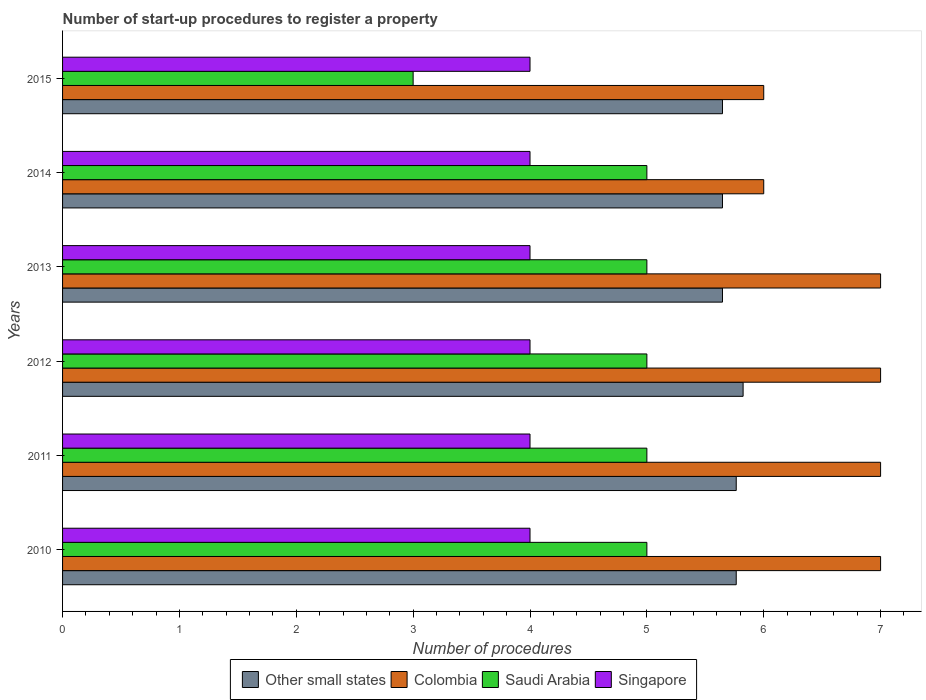How many different coloured bars are there?
Provide a succinct answer. 4. Are the number of bars per tick equal to the number of legend labels?
Keep it short and to the point. Yes. How many bars are there on the 3rd tick from the top?
Give a very brief answer. 4. In how many cases, is the number of bars for a given year not equal to the number of legend labels?
Make the answer very short. 0. What is the number of procedures required to register a property in Colombia in 2012?
Make the answer very short. 7. Across all years, what is the maximum number of procedures required to register a property in Saudi Arabia?
Keep it short and to the point. 5. Across all years, what is the minimum number of procedures required to register a property in Saudi Arabia?
Give a very brief answer. 3. In which year was the number of procedures required to register a property in Singapore maximum?
Offer a terse response. 2010. In which year was the number of procedures required to register a property in Saudi Arabia minimum?
Keep it short and to the point. 2015. What is the total number of procedures required to register a property in Singapore in the graph?
Offer a terse response. 24. What is the difference between the number of procedures required to register a property in Singapore in 2011 and that in 2012?
Your answer should be compact. 0. What is the difference between the number of procedures required to register a property in Saudi Arabia in 2010 and the number of procedures required to register a property in Other small states in 2011?
Provide a succinct answer. -0.76. What is the average number of procedures required to register a property in Other small states per year?
Make the answer very short. 5.72. In the year 2014, what is the difference between the number of procedures required to register a property in Saudi Arabia and number of procedures required to register a property in Colombia?
Give a very brief answer. -1. Is the difference between the number of procedures required to register a property in Saudi Arabia in 2011 and 2012 greater than the difference between the number of procedures required to register a property in Colombia in 2011 and 2012?
Ensure brevity in your answer.  No. What is the difference between the highest and the second highest number of procedures required to register a property in Saudi Arabia?
Keep it short and to the point. 0. What is the difference between the highest and the lowest number of procedures required to register a property in Colombia?
Offer a very short reply. 1. In how many years, is the number of procedures required to register a property in Saudi Arabia greater than the average number of procedures required to register a property in Saudi Arabia taken over all years?
Provide a succinct answer. 5. Is the sum of the number of procedures required to register a property in Singapore in 2010 and 2014 greater than the maximum number of procedures required to register a property in Other small states across all years?
Give a very brief answer. Yes. What does the 2nd bar from the top in 2015 represents?
Keep it short and to the point. Saudi Arabia. What does the 4th bar from the bottom in 2014 represents?
Offer a very short reply. Singapore. How many years are there in the graph?
Ensure brevity in your answer.  6. What is the difference between two consecutive major ticks on the X-axis?
Your response must be concise. 1. Are the values on the major ticks of X-axis written in scientific E-notation?
Ensure brevity in your answer.  No. Does the graph contain grids?
Your answer should be very brief. No. How many legend labels are there?
Keep it short and to the point. 4. What is the title of the graph?
Keep it short and to the point. Number of start-up procedures to register a property. What is the label or title of the X-axis?
Offer a terse response. Number of procedures. What is the Number of procedures of Other small states in 2010?
Offer a very short reply. 5.76. What is the Number of procedures in Colombia in 2010?
Offer a terse response. 7. What is the Number of procedures in Saudi Arabia in 2010?
Make the answer very short. 5. What is the Number of procedures of Other small states in 2011?
Ensure brevity in your answer.  5.76. What is the Number of procedures in Colombia in 2011?
Ensure brevity in your answer.  7. What is the Number of procedures in Saudi Arabia in 2011?
Provide a short and direct response. 5. What is the Number of procedures in Singapore in 2011?
Give a very brief answer. 4. What is the Number of procedures in Other small states in 2012?
Make the answer very short. 5.82. What is the Number of procedures in Colombia in 2012?
Your response must be concise. 7. What is the Number of procedures of Other small states in 2013?
Your answer should be very brief. 5.65. What is the Number of procedures in Other small states in 2014?
Keep it short and to the point. 5.65. What is the Number of procedures of Saudi Arabia in 2014?
Provide a succinct answer. 5. What is the Number of procedures in Singapore in 2014?
Provide a short and direct response. 4. What is the Number of procedures of Other small states in 2015?
Keep it short and to the point. 5.65. What is the Number of procedures of Saudi Arabia in 2015?
Keep it short and to the point. 3. What is the Number of procedures of Singapore in 2015?
Keep it short and to the point. 4. Across all years, what is the maximum Number of procedures of Other small states?
Offer a very short reply. 5.82. Across all years, what is the maximum Number of procedures in Colombia?
Offer a very short reply. 7. Across all years, what is the maximum Number of procedures in Saudi Arabia?
Your answer should be very brief. 5. Across all years, what is the maximum Number of procedures of Singapore?
Offer a very short reply. 4. Across all years, what is the minimum Number of procedures in Other small states?
Give a very brief answer. 5.65. Across all years, what is the minimum Number of procedures in Saudi Arabia?
Offer a very short reply. 3. What is the total Number of procedures of Other small states in the graph?
Ensure brevity in your answer.  34.29. What is the total Number of procedures of Colombia in the graph?
Your response must be concise. 40. What is the total Number of procedures in Singapore in the graph?
Give a very brief answer. 24. What is the difference between the Number of procedures in Colombia in 2010 and that in 2011?
Your answer should be very brief. 0. What is the difference between the Number of procedures in Singapore in 2010 and that in 2011?
Give a very brief answer. 0. What is the difference between the Number of procedures in Other small states in 2010 and that in 2012?
Your response must be concise. -0.06. What is the difference between the Number of procedures in Colombia in 2010 and that in 2012?
Provide a succinct answer. 0. What is the difference between the Number of procedures in Saudi Arabia in 2010 and that in 2012?
Keep it short and to the point. 0. What is the difference between the Number of procedures in Singapore in 2010 and that in 2012?
Offer a terse response. 0. What is the difference between the Number of procedures in Other small states in 2010 and that in 2013?
Give a very brief answer. 0.12. What is the difference between the Number of procedures of Saudi Arabia in 2010 and that in 2013?
Give a very brief answer. 0. What is the difference between the Number of procedures in Other small states in 2010 and that in 2014?
Provide a succinct answer. 0.12. What is the difference between the Number of procedures in Saudi Arabia in 2010 and that in 2014?
Offer a terse response. 0. What is the difference between the Number of procedures of Singapore in 2010 and that in 2014?
Ensure brevity in your answer.  0. What is the difference between the Number of procedures in Other small states in 2010 and that in 2015?
Provide a short and direct response. 0.12. What is the difference between the Number of procedures of Saudi Arabia in 2010 and that in 2015?
Give a very brief answer. 2. What is the difference between the Number of procedures of Singapore in 2010 and that in 2015?
Give a very brief answer. 0. What is the difference between the Number of procedures in Other small states in 2011 and that in 2012?
Provide a short and direct response. -0.06. What is the difference between the Number of procedures in Saudi Arabia in 2011 and that in 2012?
Keep it short and to the point. 0. What is the difference between the Number of procedures of Other small states in 2011 and that in 2013?
Your answer should be very brief. 0.12. What is the difference between the Number of procedures of Other small states in 2011 and that in 2014?
Ensure brevity in your answer.  0.12. What is the difference between the Number of procedures in Colombia in 2011 and that in 2014?
Provide a succinct answer. 1. What is the difference between the Number of procedures of Saudi Arabia in 2011 and that in 2014?
Give a very brief answer. 0. What is the difference between the Number of procedures of Other small states in 2011 and that in 2015?
Offer a very short reply. 0.12. What is the difference between the Number of procedures in Colombia in 2011 and that in 2015?
Provide a short and direct response. 1. What is the difference between the Number of procedures in Saudi Arabia in 2011 and that in 2015?
Give a very brief answer. 2. What is the difference between the Number of procedures of Other small states in 2012 and that in 2013?
Offer a terse response. 0.18. What is the difference between the Number of procedures in Colombia in 2012 and that in 2013?
Provide a succinct answer. 0. What is the difference between the Number of procedures in Other small states in 2012 and that in 2014?
Ensure brevity in your answer.  0.18. What is the difference between the Number of procedures of Saudi Arabia in 2012 and that in 2014?
Offer a terse response. 0. What is the difference between the Number of procedures of Singapore in 2012 and that in 2014?
Provide a succinct answer. 0. What is the difference between the Number of procedures of Other small states in 2012 and that in 2015?
Offer a terse response. 0.18. What is the difference between the Number of procedures in Colombia in 2012 and that in 2015?
Provide a short and direct response. 1. What is the difference between the Number of procedures in Saudi Arabia in 2012 and that in 2015?
Keep it short and to the point. 2. What is the difference between the Number of procedures in Singapore in 2012 and that in 2015?
Make the answer very short. 0. What is the difference between the Number of procedures of Other small states in 2013 and that in 2014?
Your answer should be very brief. 0. What is the difference between the Number of procedures in Colombia in 2013 and that in 2014?
Offer a terse response. 1. What is the difference between the Number of procedures in Singapore in 2013 and that in 2014?
Provide a succinct answer. 0. What is the difference between the Number of procedures of Colombia in 2013 and that in 2015?
Offer a very short reply. 1. What is the difference between the Number of procedures of Saudi Arabia in 2013 and that in 2015?
Keep it short and to the point. 2. What is the difference between the Number of procedures in Other small states in 2014 and that in 2015?
Ensure brevity in your answer.  0. What is the difference between the Number of procedures of Colombia in 2014 and that in 2015?
Keep it short and to the point. 0. What is the difference between the Number of procedures in Saudi Arabia in 2014 and that in 2015?
Your response must be concise. 2. What is the difference between the Number of procedures in Singapore in 2014 and that in 2015?
Offer a very short reply. 0. What is the difference between the Number of procedures in Other small states in 2010 and the Number of procedures in Colombia in 2011?
Provide a short and direct response. -1.24. What is the difference between the Number of procedures of Other small states in 2010 and the Number of procedures of Saudi Arabia in 2011?
Provide a succinct answer. 0.76. What is the difference between the Number of procedures of Other small states in 2010 and the Number of procedures of Singapore in 2011?
Provide a short and direct response. 1.76. What is the difference between the Number of procedures of Saudi Arabia in 2010 and the Number of procedures of Singapore in 2011?
Ensure brevity in your answer.  1. What is the difference between the Number of procedures of Other small states in 2010 and the Number of procedures of Colombia in 2012?
Provide a succinct answer. -1.24. What is the difference between the Number of procedures of Other small states in 2010 and the Number of procedures of Saudi Arabia in 2012?
Provide a short and direct response. 0.76. What is the difference between the Number of procedures in Other small states in 2010 and the Number of procedures in Singapore in 2012?
Offer a very short reply. 1.76. What is the difference between the Number of procedures in Colombia in 2010 and the Number of procedures in Singapore in 2012?
Keep it short and to the point. 3. What is the difference between the Number of procedures of Saudi Arabia in 2010 and the Number of procedures of Singapore in 2012?
Keep it short and to the point. 1. What is the difference between the Number of procedures of Other small states in 2010 and the Number of procedures of Colombia in 2013?
Keep it short and to the point. -1.24. What is the difference between the Number of procedures of Other small states in 2010 and the Number of procedures of Saudi Arabia in 2013?
Make the answer very short. 0.76. What is the difference between the Number of procedures in Other small states in 2010 and the Number of procedures in Singapore in 2013?
Provide a succinct answer. 1.76. What is the difference between the Number of procedures in Colombia in 2010 and the Number of procedures in Saudi Arabia in 2013?
Ensure brevity in your answer.  2. What is the difference between the Number of procedures in Colombia in 2010 and the Number of procedures in Singapore in 2013?
Provide a short and direct response. 3. What is the difference between the Number of procedures in Saudi Arabia in 2010 and the Number of procedures in Singapore in 2013?
Make the answer very short. 1. What is the difference between the Number of procedures of Other small states in 2010 and the Number of procedures of Colombia in 2014?
Offer a very short reply. -0.24. What is the difference between the Number of procedures of Other small states in 2010 and the Number of procedures of Saudi Arabia in 2014?
Make the answer very short. 0.76. What is the difference between the Number of procedures in Other small states in 2010 and the Number of procedures in Singapore in 2014?
Offer a terse response. 1.76. What is the difference between the Number of procedures of Colombia in 2010 and the Number of procedures of Saudi Arabia in 2014?
Your answer should be very brief. 2. What is the difference between the Number of procedures of Other small states in 2010 and the Number of procedures of Colombia in 2015?
Offer a terse response. -0.24. What is the difference between the Number of procedures in Other small states in 2010 and the Number of procedures in Saudi Arabia in 2015?
Ensure brevity in your answer.  2.76. What is the difference between the Number of procedures of Other small states in 2010 and the Number of procedures of Singapore in 2015?
Offer a very short reply. 1.76. What is the difference between the Number of procedures in Colombia in 2010 and the Number of procedures in Saudi Arabia in 2015?
Provide a short and direct response. 4. What is the difference between the Number of procedures in Colombia in 2010 and the Number of procedures in Singapore in 2015?
Give a very brief answer. 3. What is the difference between the Number of procedures of Saudi Arabia in 2010 and the Number of procedures of Singapore in 2015?
Provide a succinct answer. 1. What is the difference between the Number of procedures in Other small states in 2011 and the Number of procedures in Colombia in 2012?
Your answer should be compact. -1.24. What is the difference between the Number of procedures of Other small states in 2011 and the Number of procedures of Saudi Arabia in 2012?
Make the answer very short. 0.76. What is the difference between the Number of procedures in Other small states in 2011 and the Number of procedures in Singapore in 2012?
Your answer should be very brief. 1.76. What is the difference between the Number of procedures in Saudi Arabia in 2011 and the Number of procedures in Singapore in 2012?
Keep it short and to the point. 1. What is the difference between the Number of procedures in Other small states in 2011 and the Number of procedures in Colombia in 2013?
Offer a terse response. -1.24. What is the difference between the Number of procedures of Other small states in 2011 and the Number of procedures of Saudi Arabia in 2013?
Provide a short and direct response. 0.76. What is the difference between the Number of procedures of Other small states in 2011 and the Number of procedures of Singapore in 2013?
Give a very brief answer. 1.76. What is the difference between the Number of procedures of Colombia in 2011 and the Number of procedures of Saudi Arabia in 2013?
Provide a succinct answer. 2. What is the difference between the Number of procedures in Other small states in 2011 and the Number of procedures in Colombia in 2014?
Your answer should be very brief. -0.24. What is the difference between the Number of procedures of Other small states in 2011 and the Number of procedures of Saudi Arabia in 2014?
Give a very brief answer. 0.76. What is the difference between the Number of procedures in Other small states in 2011 and the Number of procedures in Singapore in 2014?
Your answer should be compact. 1.76. What is the difference between the Number of procedures of Colombia in 2011 and the Number of procedures of Singapore in 2014?
Keep it short and to the point. 3. What is the difference between the Number of procedures of Other small states in 2011 and the Number of procedures of Colombia in 2015?
Your answer should be very brief. -0.24. What is the difference between the Number of procedures in Other small states in 2011 and the Number of procedures in Saudi Arabia in 2015?
Keep it short and to the point. 2.76. What is the difference between the Number of procedures in Other small states in 2011 and the Number of procedures in Singapore in 2015?
Make the answer very short. 1.76. What is the difference between the Number of procedures of Colombia in 2011 and the Number of procedures of Saudi Arabia in 2015?
Offer a terse response. 4. What is the difference between the Number of procedures of Saudi Arabia in 2011 and the Number of procedures of Singapore in 2015?
Provide a short and direct response. 1. What is the difference between the Number of procedures of Other small states in 2012 and the Number of procedures of Colombia in 2013?
Provide a succinct answer. -1.18. What is the difference between the Number of procedures of Other small states in 2012 and the Number of procedures of Saudi Arabia in 2013?
Offer a very short reply. 0.82. What is the difference between the Number of procedures in Other small states in 2012 and the Number of procedures in Singapore in 2013?
Make the answer very short. 1.82. What is the difference between the Number of procedures of Colombia in 2012 and the Number of procedures of Saudi Arabia in 2013?
Your answer should be very brief. 2. What is the difference between the Number of procedures in Saudi Arabia in 2012 and the Number of procedures in Singapore in 2013?
Give a very brief answer. 1. What is the difference between the Number of procedures of Other small states in 2012 and the Number of procedures of Colombia in 2014?
Keep it short and to the point. -0.18. What is the difference between the Number of procedures of Other small states in 2012 and the Number of procedures of Saudi Arabia in 2014?
Give a very brief answer. 0.82. What is the difference between the Number of procedures in Other small states in 2012 and the Number of procedures in Singapore in 2014?
Keep it short and to the point. 1.82. What is the difference between the Number of procedures of Colombia in 2012 and the Number of procedures of Singapore in 2014?
Give a very brief answer. 3. What is the difference between the Number of procedures in Other small states in 2012 and the Number of procedures in Colombia in 2015?
Your response must be concise. -0.18. What is the difference between the Number of procedures of Other small states in 2012 and the Number of procedures of Saudi Arabia in 2015?
Your response must be concise. 2.82. What is the difference between the Number of procedures in Other small states in 2012 and the Number of procedures in Singapore in 2015?
Your answer should be very brief. 1.82. What is the difference between the Number of procedures in Colombia in 2012 and the Number of procedures in Saudi Arabia in 2015?
Your response must be concise. 4. What is the difference between the Number of procedures of Saudi Arabia in 2012 and the Number of procedures of Singapore in 2015?
Keep it short and to the point. 1. What is the difference between the Number of procedures of Other small states in 2013 and the Number of procedures of Colombia in 2014?
Keep it short and to the point. -0.35. What is the difference between the Number of procedures in Other small states in 2013 and the Number of procedures in Saudi Arabia in 2014?
Offer a terse response. 0.65. What is the difference between the Number of procedures in Other small states in 2013 and the Number of procedures in Singapore in 2014?
Ensure brevity in your answer.  1.65. What is the difference between the Number of procedures of Colombia in 2013 and the Number of procedures of Saudi Arabia in 2014?
Ensure brevity in your answer.  2. What is the difference between the Number of procedures of Colombia in 2013 and the Number of procedures of Singapore in 2014?
Your answer should be very brief. 3. What is the difference between the Number of procedures in Other small states in 2013 and the Number of procedures in Colombia in 2015?
Your answer should be very brief. -0.35. What is the difference between the Number of procedures in Other small states in 2013 and the Number of procedures in Saudi Arabia in 2015?
Offer a very short reply. 2.65. What is the difference between the Number of procedures of Other small states in 2013 and the Number of procedures of Singapore in 2015?
Your answer should be very brief. 1.65. What is the difference between the Number of procedures of Colombia in 2013 and the Number of procedures of Singapore in 2015?
Provide a succinct answer. 3. What is the difference between the Number of procedures of Saudi Arabia in 2013 and the Number of procedures of Singapore in 2015?
Offer a very short reply. 1. What is the difference between the Number of procedures of Other small states in 2014 and the Number of procedures of Colombia in 2015?
Provide a short and direct response. -0.35. What is the difference between the Number of procedures in Other small states in 2014 and the Number of procedures in Saudi Arabia in 2015?
Your answer should be very brief. 2.65. What is the difference between the Number of procedures in Other small states in 2014 and the Number of procedures in Singapore in 2015?
Offer a terse response. 1.65. What is the difference between the Number of procedures in Colombia in 2014 and the Number of procedures in Singapore in 2015?
Your answer should be very brief. 2. What is the average Number of procedures in Other small states per year?
Give a very brief answer. 5.72. What is the average Number of procedures in Saudi Arabia per year?
Give a very brief answer. 4.67. What is the average Number of procedures in Singapore per year?
Your answer should be very brief. 4. In the year 2010, what is the difference between the Number of procedures of Other small states and Number of procedures of Colombia?
Give a very brief answer. -1.24. In the year 2010, what is the difference between the Number of procedures in Other small states and Number of procedures in Saudi Arabia?
Provide a succinct answer. 0.76. In the year 2010, what is the difference between the Number of procedures in Other small states and Number of procedures in Singapore?
Your response must be concise. 1.76. In the year 2010, what is the difference between the Number of procedures in Colombia and Number of procedures in Saudi Arabia?
Ensure brevity in your answer.  2. In the year 2010, what is the difference between the Number of procedures in Saudi Arabia and Number of procedures in Singapore?
Offer a terse response. 1. In the year 2011, what is the difference between the Number of procedures in Other small states and Number of procedures in Colombia?
Make the answer very short. -1.24. In the year 2011, what is the difference between the Number of procedures of Other small states and Number of procedures of Saudi Arabia?
Offer a terse response. 0.76. In the year 2011, what is the difference between the Number of procedures of Other small states and Number of procedures of Singapore?
Your response must be concise. 1.76. In the year 2011, what is the difference between the Number of procedures of Colombia and Number of procedures of Saudi Arabia?
Your response must be concise. 2. In the year 2011, what is the difference between the Number of procedures in Colombia and Number of procedures in Singapore?
Provide a succinct answer. 3. In the year 2012, what is the difference between the Number of procedures of Other small states and Number of procedures of Colombia?
Ensure brevity in your answer.  -1.18. In the year 2012, what is the difference between the Number of procedures in Other small states and Number of procedures in Saudi Arabia?
Offer a terse response. 0.82. In the year 2012, what is the difference between the Number of procedures of Other small states and Number of procedures of Singapore?
Offer a terse response. 1.82. In the year 2013, what is the difference between the Number of procedures in Other small states and Number of procedures in Colombia?
Provide a succinct answer. -1.35. In the year 2013, what is the difference between the Number of procedures of Other small states and Number of procedures of Saudi Arabia?
Your response must be concise. 0.65. In the year 2013, what is the difference between the Number of procedures in Other small states and Number of procedures in Singapore?
Provide a short and direct response. 1.65. In the year 2013, what is the difference between the Number of procedures of Colombia and Number of procedures of Singapore?
Your response must be concise. 3. In the year 2013, what is the difference between the Number of procedures of Saudi Arabia and Number of procedures of Singapore?
Give a very brief answer. 1. In the year 2014, what is the difference between the Number of procedures in Other small states and Number of procedures in Colombia?
Offer a very short reply. -0.35. In the year 2014, what is the difference between the Number of procedures in Other small states and Number of procedures in Saudi Arabia?
Offer a very short reply. 0.65. In the year 2014, what is the difference between the Number of procedures in Other small states and Number of procedures in Singapore?
Your answer should be very brief. 1.65. In the year 2014, what is the difference between the Number of procedures of Colombia and Number of procedures of Saudi Arabia?
Your answer should be compact. 1. In the year 2014, what is the difference between the Number of procedures of Saudi Arabia and Number of procedures of Singapore?
Make the answer very short. 1. In the year 2015, what is the difference between the Number of procedures in Other small states and Number of procedures in Colombia?
Your answer should be compact. -0.35. In the year 2015, what is the difference between the Number of procedures of Other small states and Number of procedures of Saudi Arabia?
Provide a short and direct response. 2.65. In the year 2015, what is the difference between the Number of procedures in Other small states and Number of procedures in Singapore?
Offer a very short reply. 1.65. In the year 2015, what is the difference between the Number of procedures of Colombia and Number of procedures of Saudi Arabia?
Your answer should be compact. 3. In the year 2015, what is the difference between the Number of procedures in Colombia and Number of procedures in Singapore?
Provide a short and direct response. 2. In the year 2015, what is the difference between the Number of procedures of Saudi Arabia and Number of procedures of Singapore?
Make the answer very short. -1. What is the ratio of the Number of procedures of Other small states in 2010 to that in 2011?
Your response must be concise. 1. What is the ratio of the Number of procedures of Colombia in 2010 to that in 2011?
Offer a terse response. 1. What is the ratio of the Number of procedures of Singapore in 2010 to that in 2011?
Keep it short and to the point. 1. What is the ratio of the Number of procedures of Other small states in 2010 to that in 2012?
Offer a very short reply. 0.99. What is the ratio of the Number of procedures of Colombia in 2010 to that in 2012?
Provide a succinct answer. 1. What is the ratio of the Number of procedures in Singapore in 2010 to that in 2012?
Make the answer very short. 1. What is the ratio of the Number of procedures in Other small states in 2010 to that in 2013?
Give a very brief answer. 1.02. What is the ratio of the Number of procedures in Colombia in 2010 to that in 2013?
Provide a succinct answer. 1. What is the ratio of the Number of procedures of Singapore in 2010 to that in 2013?
Your answer should be very brief. 1. What is the ratio of the Number of procedures of Other small states in 2010 to that in 2014?
Provide a succinct answer. 1.02. What is the ratio of the Number of procedures of Saudi Arabia in 2010 to that in 2014?
Offer a terse response. 1. What is the ratio of the Number of procedures of Other small states in 2010 to that in 2015?
Ensure brevity in your answer.  1.02. What is the ratio of the Number of procedures in Saudi Arabia in 2011 to that in 2012?
Keep it short and to the point. 1. What is the ratio of the Number of procedures in Other small states in 2011 to that in 2013?
Offer a terse response. 1.02. What is the ratio of the Number of procedures in Other small states in 2011 to that in 2014?
Ensure brevity in your answer.  1.02. What is the ratio of the Number of procedures of Other small states in 2011 to that in 2015?
Your response must be concise. 1.02. What is the ratio of the Number of procedures of Saudi Arabia in 2011 to that in 2015?
Make the answer very short. 1.67. What is the ratio of the Number of procedures in Singapore in 2011 to that in 2015?
Your answer should be compact. 1. What is the ratio of the Number of procedures of Other small states in 2012 to that in 2013?
Your answer should be compact. 1.03. What is the ratio of the Number of procedures in Colombia in 2012 to that in 2013?
Give a very brief answer. 1. What is the ratio of the Number of procedures in Other small states in 2012 to that in 2014?
Offer a very short reply. 1.03. What is the ratio of the Number of procedures of Singapore in 2012 to that in 2014?
Your response must be concise. 1. What is the ratio of the Number of procedures of Other small states in 2012 to that in 2015?
Provide a short and direct response. 1.03. What is the ratio of the Number of procedures in Singapore in 2012 to that in 2015?
Your answer should be compact. 1. What is the ratio of the Number of procedures in Other small states in 2013 to that in 2014?
Provide a short and direct response. 1. What is the ratio of the Number of procedures of Saudi Arabia in 2013 to that in 2014?
Keep it short and to the point. 1. What is the ratio of the Number of procedures in Singapore in 2013 to that in 2014?
Your answer should be very brief. 1. What is the ratio of the Number of procedures of Colombia in 2013 to that in 2015?
Make the answer very short. 1.17. What is the ratio of the Number of procedures in Saudi Arabia in 2013 to that in 2015?
Your response must be concise. 1.67. What is the ratio of the Number of procedures of Other small states in 2014 to that in 2015?
Provide a succinct answer. 1. What is the ratio of the Number of procedures of Colombia in 2014 to that in 2015?
Provide a succinct answer. 1. What is the difference between the highest and the second highest Number of procedures of Other small states?
Your answer should be very brief. 0.06. What is the difference between the highest and the second highest Number of procedures in Colombia?
Offer a terse response. 0. What is the difference between the highest and the second highest Number of procedures of Singapore?
Offer a terse response. 0. What is the difference between the highest and the lowest Number of procedures of Other small states?
Your answer should be compact. 0.18. What is the difference between the highest and the lowest Number of procedures in Colombia?
Provide a short and direct response. 1. What is the difference between the highest and the lowest Number of procedures in Saudi Arabia?
Give a very brief answer. 2. 